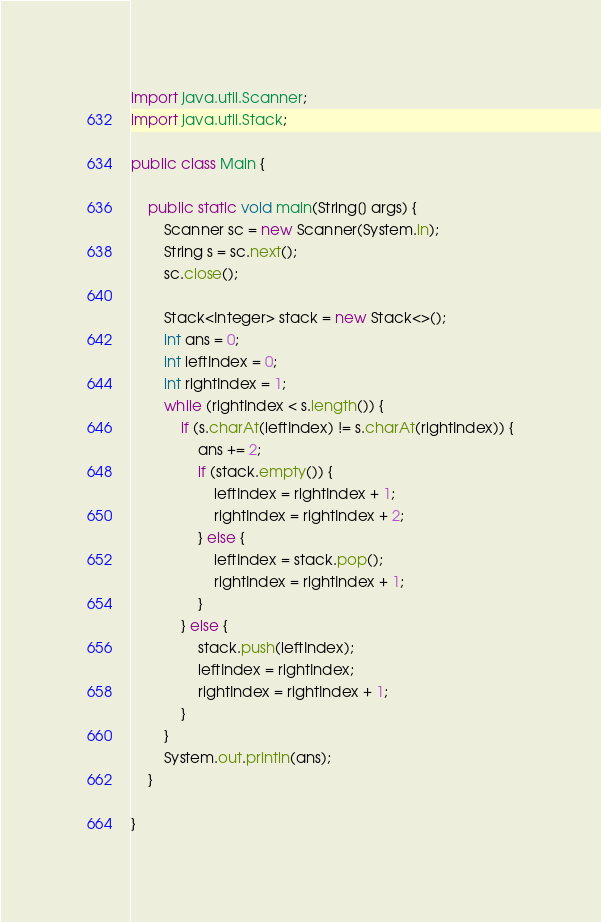Convert code to text. <code><loc_0><loc_0><loc_500><loc_500><_Java_>import java.util.Scanner;
import java.util.Stack;

public class Main {

    public static void main(String[] args) {
        Scanner sc = new Scanner(System.in);
        String s = sc.next();
        sc.close();

        Stack<Integer> stack = new Stack<>();
        int ans = 0;
        int leftIndex = 0;
        int rightIndex = 1;
        while (rightIndex < s.length()) {
            if (s.charAt(leftIndex) != s.charAt(rightIndex)) {
                ans += 2;
                if (stack.empty()) {
                    leftIndex = rightIndex + 1;
                    rightIndex = rightIndex + 2;
                } else {
                    leftIndex = stack.pop();
                    rightIndex = rightIndex + 1;
                }
            } else {
                stack.push(leftIndex);
                leftIndex = rightIndex;
                rightIndex = rightIndex + 1;
            }
        }
        System.out.println(ans);
    }

}
</code> 